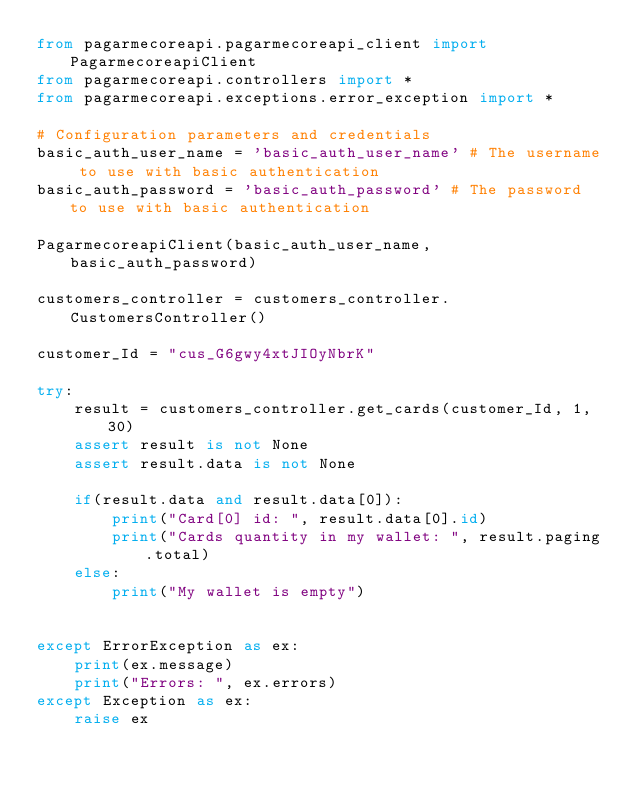Convert code to text. <code><loc_0><loc_0><loc_500><loc_500><_Python_>from pagarmecoreapi.pagarmecoreapi_client import PagarmecoreapiClient
from pagarmecoreapi.controllers import *
from pagarmecoreapi.exceptions.error_exception import *

# Configuration parameters and credentials
basic_auth_user_name = 'basic_auth_user_name' # The username to use with basic authentication
basic_auth_password = 'basic_auth_password' # The password to use with basic authentication

PagarmecoreapiClient(basic_auth_user_name, basic_auth_password)

customers_controller = customers_controller.CustomersController()

customer_Id = "cus_G6gwy4xtJIOyNbrK"

try:
    result = customers_controller.get_cards(customer_Id, 1, 30)
    assert result is not None
    assert result.data is not None

    if(result.data and result.data[0]):
        print("Card[0] id: ", result.data[0].id)
        print("Cards quantity in my wallet: ", result.paging.total)
    else:
        print("My wallet is empty")


except ErrorException as ex:
    print(ex.message)
    print("Errors: ", ex.errors)
except Exception as ex:
    raise ex
    </code> 